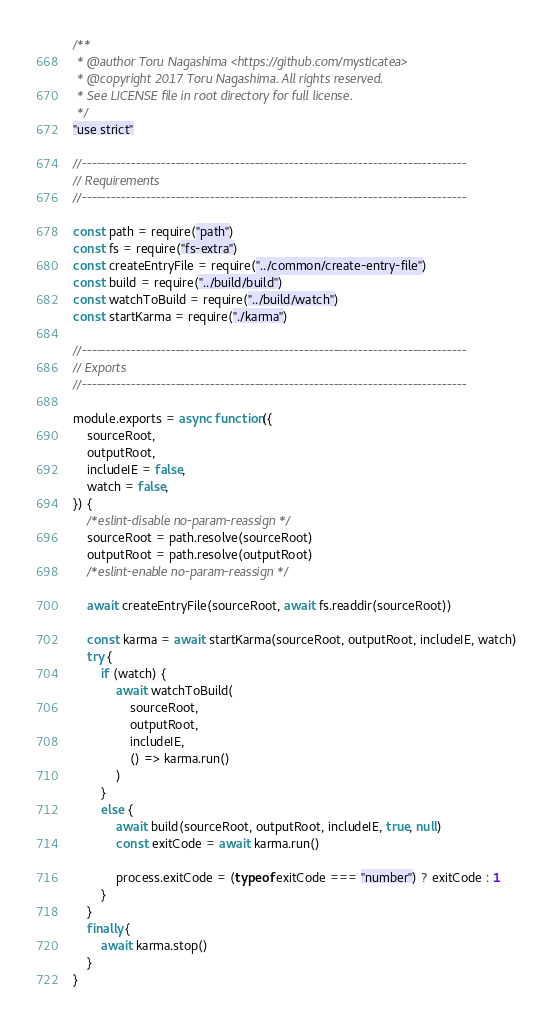<code> <loc_0><loc_0><loc_500><loc_500><_JavaScript_>/**
 * @author Toru Nagashima <https://github.com/mysticatea>
 * @copyright 2017 Toru Nagashima. All rights reserved.
 * See LICENSE file in root directory for full license.
 */
"use strict"

//------------------------------------------------------------------------------
// Requirements
//------------------------------------------------------------------------------

const path = require("path")
const fs = require("fs-extra")
const createEntryFile = require("../common/create-entry-file")
const build = require("../build/build")
const watchToBuild = require("../build/watch")
const startKarma = require("./karma")

//------------------------------------------------------------------------------
// Exports
//------------------------------------------------------------------------------

module.exports = async function({
    sourceRoot,
    outputRoot,
    includeIE = false,
    watch = false,
}) {
    /*eslint-disable no-param-reassign */
    sourceRoot = path.resolve(sourceRoot)
    outputRoot = path.resolve(outputRoot)
    /*eslint-enable no-param-reassign */

    await createEntryFile(sourceRoot, await fs.readdir(sourceRoot))

    const karma = await startKarma(sourceRoot, outputRoot, includeIE, watch)
    try {
        if (watch) {
            await watchToBuild(
                sourceRoot,
                outputRoot,
                includeIE,
                () => karma.run()
            )
        }
        else {
            await build(sourceRoot, outputRoot, includeIE, true, null)
            const exitCode = await karma.run()

            process.exitCode = (typeof exitCode === "number") ? exitCode : 1
        }
    }
    finally {
        await karma.stop()
    }
}
</code> 